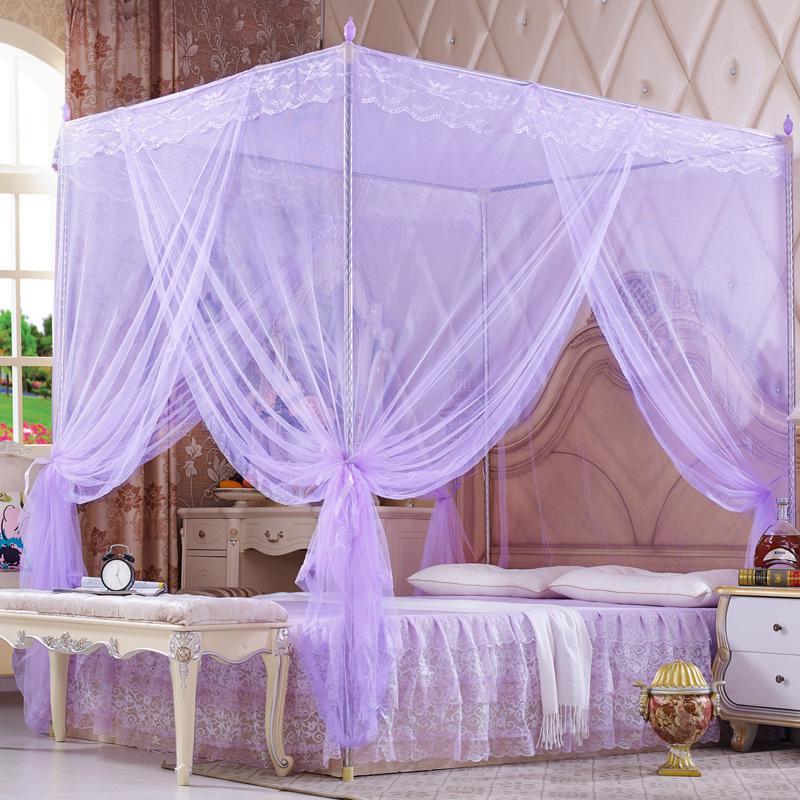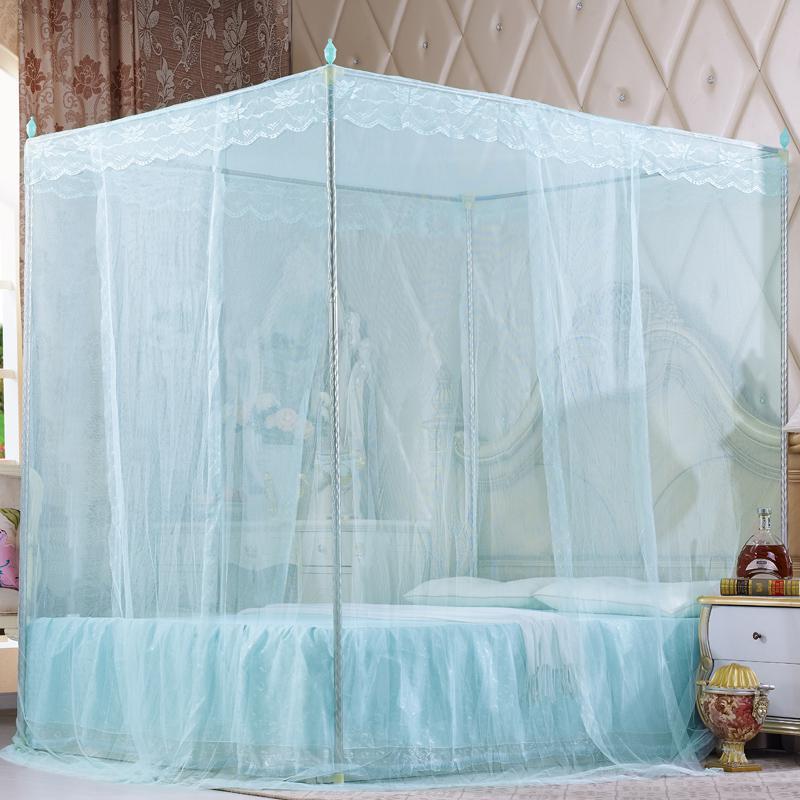The first image is the image on the left, the second image is the image on the right. Assess this claim about the two images: "Green bed drapes are tied on to bed poles.". Correct or not? Answer yes or no. No. 